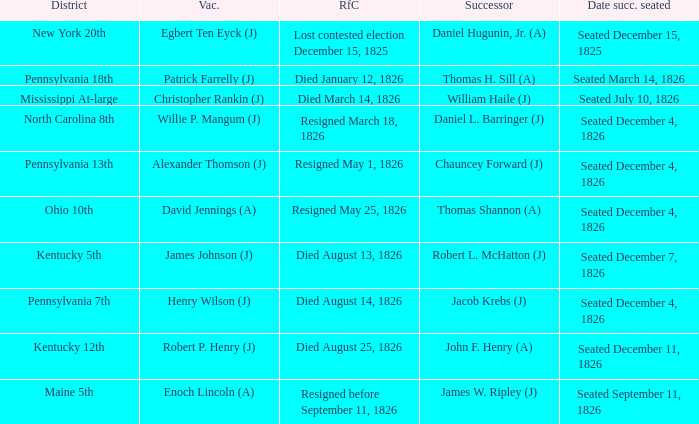Name the vacator for died august 13, 1826 James Johnson (J). 